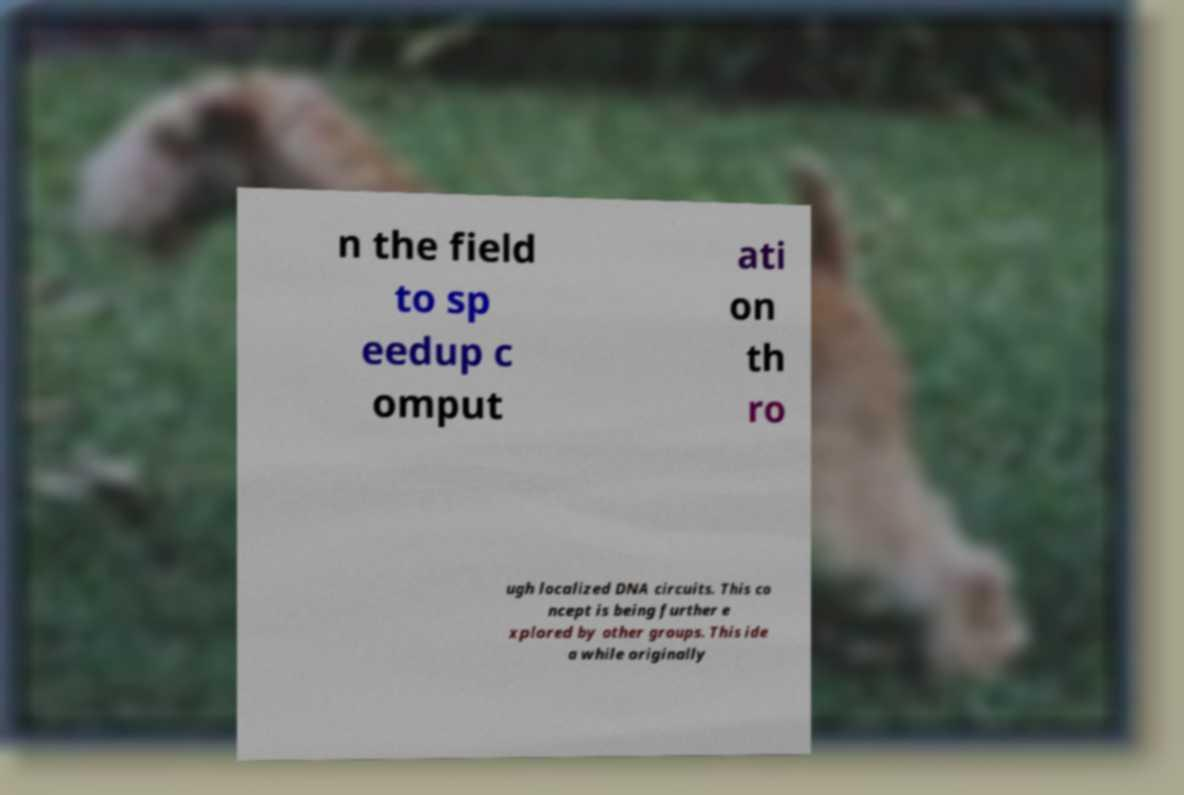Please identify and transcribe the text found in this image. n the field to sp eedup c omput ati on th ro ugh localized DNA circuits. This co ncept is being further e xplored by other groups. This ide a while originally 